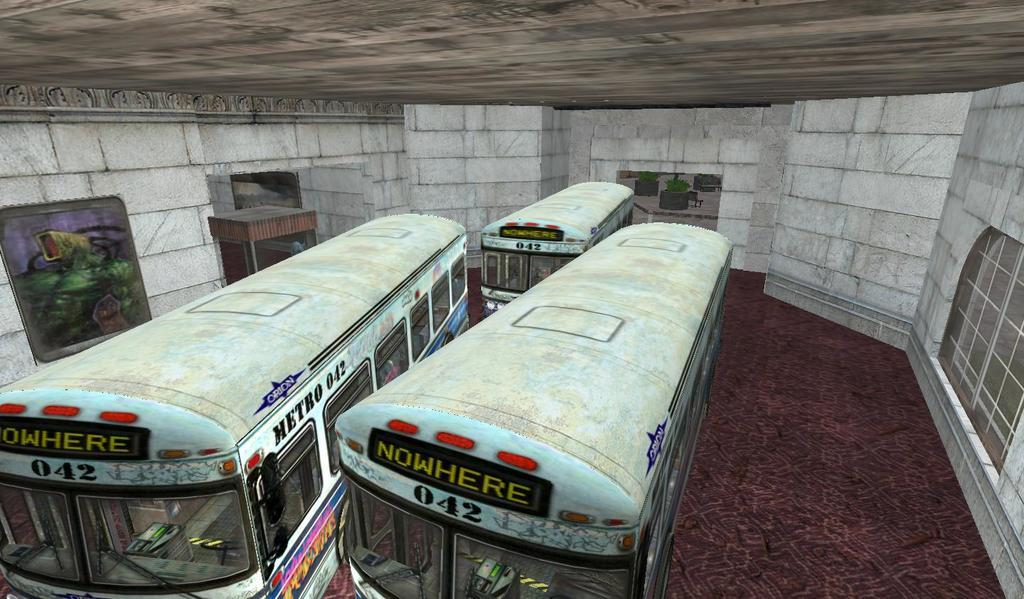What type of image is being described? The image is animated. What objects are on the floor in the image? There are three buses on the floor. What can be seen in the background of the image? There is a wall in the background. What features are present on the wall? Windows and frames are attached to the wall. How many bees can be seen flying around the buses in the image? There are no bees present in the image; it features three buses on the floor and a wall in the background. What type of air is visible in the image? The image is animated, but there is no specific type of air visible in the image. 